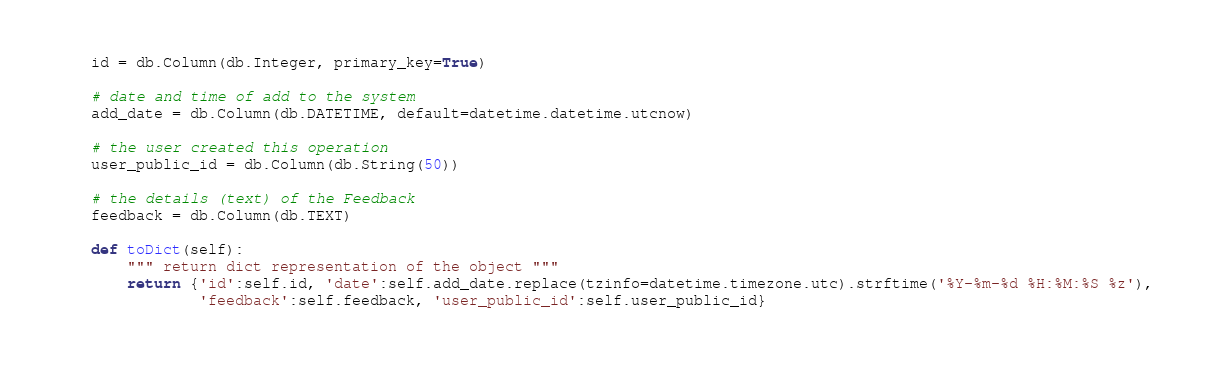<code> <loc_0><loc_0><loc_500><loc_500><_Python_>	id = db.Column(db.Integer, primary_key=True)

	# date and time of add to the system
	add_date = db.Column(db.DATETIME, default=datetime.datetime.utcnow)

	# the user created this operation
	user_public_id = db.Column(db.String(50))

	# the details (text) of the Feedback
	feedback = db.Column(db.TEXT)

	def toDict(self):
		""" return dict representation of the object """
		return {'id':self.id, 'date':self.add_date.replace(tzinfo=datetime.timezone.utc).strftime('%Y-%m-%d %H:%M:%S %z'),
				'feedback':self.feedback, 'user_public_id':self.user_public_id}</code> 